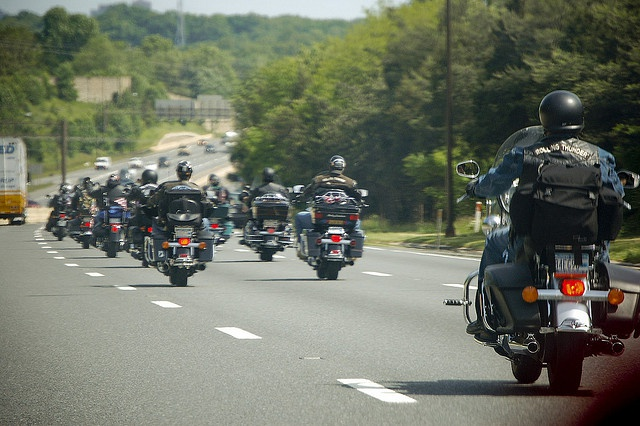Describe the objects in this image and their specific colors. I can see motorcycle in darkgray, black, gray, and maroon tones, people in darkgray, black, gray, and darkblue tones, backpack in darkgray, black, and gray tones, motorcycle in darkgray, black, gray, and blue tones, and motorcycle in darkgray, black, gray, and purple tones in this image. 